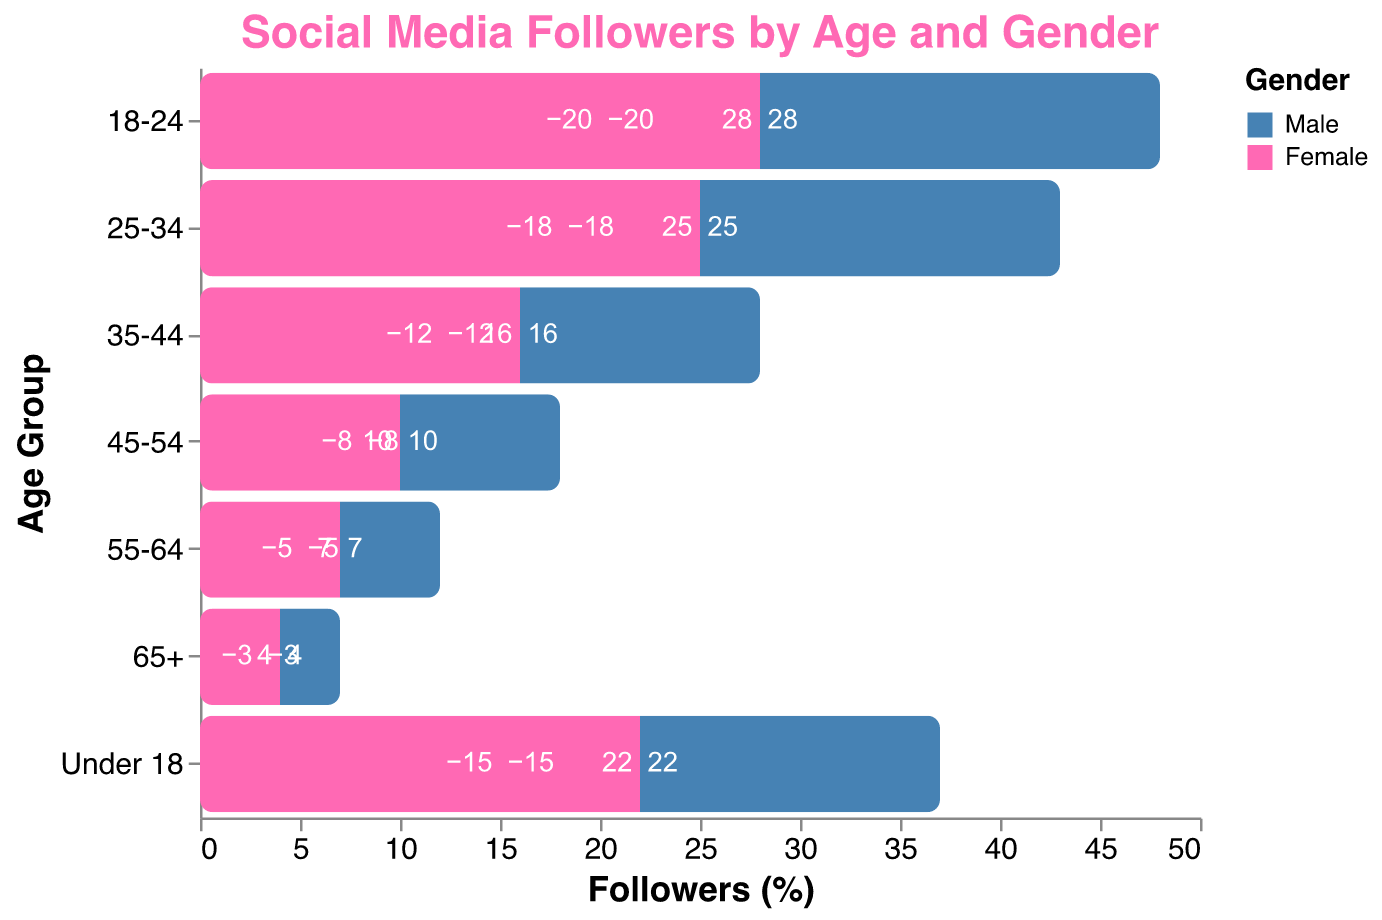What's the title of the figure? The title can be found at the top of the figure, displayed prominently.
Answer: Social Media Followers by Age and Gender What age group has the most followers overall? To find out which age group has the most followers, add up the Male and Female followers for each age group and compare the totals. For example, "Under 18" has 15 (Male) + 22 (Female) = 37. Do this for all age groups and compare.
Answer: 18-24 How many female followers are in the 25-34 age group? Look for the bar labeled "25-34" under the "Age Group" axis and find the segment representing Female followers.
Answer: 25 Which gender has more followers in the 35-44 age group? Compare the lengths of the bars for Male and Female in the "35-44" age group. The longer bar indicates the gender with more followers.
Answer: Female What is the total number of male followers aged 45+? Add up the male followers from the 45-54, 55-64, and 65+ age groups: 8 (45-54) + 5 (55-64) + 3 (65+).
Answer: 16 In the 55-64 age group, what is the percentage of female followers compared to the total number of followers in that group? To find the percentage of female followers: 
1. Add male and female followers in the 55-64 age group: 5 (Male) + 7 (Female) = 12 (Total).
2. Calculate the percentage: (7 / 12) * 100.
Answer: ~58.33% How many age groups have more male followers than female followers? Compare the lengths of male and female bars for each age group and count those where the male bar is longer.
Answer: None What's the difference between male and female followers in the 18-24 age group? Subtract the number of male followers from the number of female followers in the 18-24 age group: 28 (Female) - 20 (Male).
Answer: 8 In which age group do females constitute the highest number of followers? Compare the values of female followers across all age groups and identify the highest number.
Answer: 18-24 